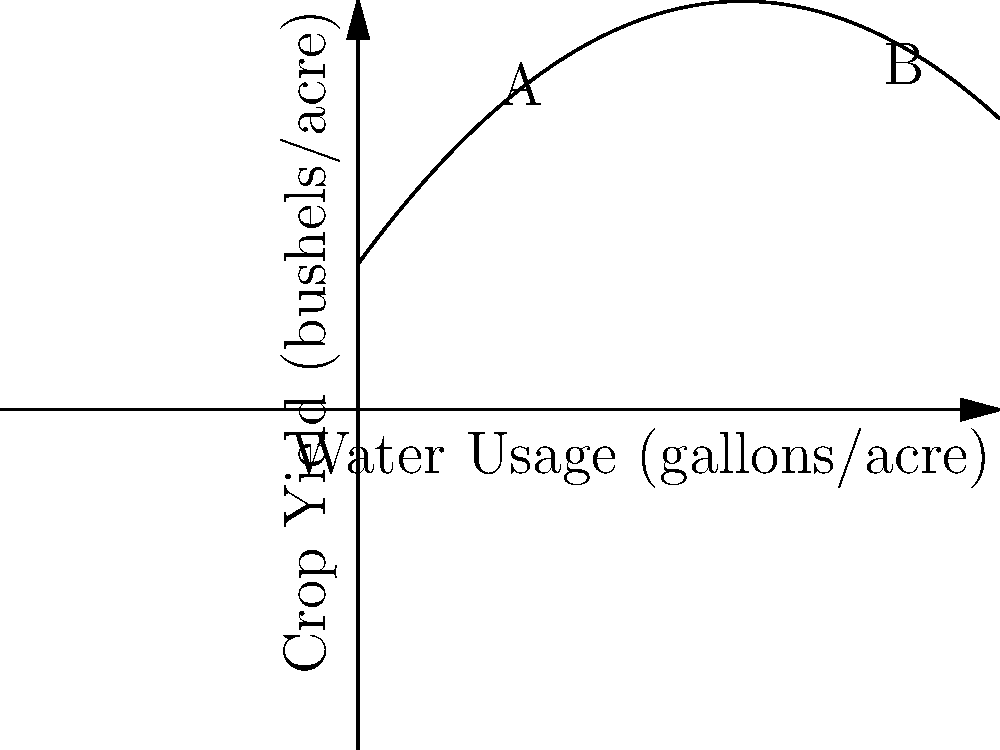A farmer is studying the relationship between water usage and crop yield for a new irrigation system. The polynomial $f(x)=-0.5x^2+6x+10$ models the crop yield (in bushels per acre) as a function of water usage (in gallons per acre), where $x$ represents hundreds of gallons. If the farmer increases water usage from 200 to 800 gallons per acre, what is the change in crop yield? To solve this problem, we need to follow these steps:

1) The water usage is given in hundreds of gallons, so:
   200 gallons = 2 hundred gallons
   800 gallons = 8 hundred gallons

2) We need to calculate the crop yield at these two points:

   At 200 gallons (x = 2):
   $f(2) = -0.5(2)^2 + 6(2) + 10$
   $= -0.5(4) + 12 + 10$
   $= -2 + 12 + 10 = 20$ bushels per acre

   At 800 gallons (x = 8):
   $f(8) = -0.5(8)^2 + 6(8) + 10$
   $= -0.5(64) + 48 + 10$
   $= -32 + 48 + 10 = 26$ bushels per acre

3) The change in crop yield is the difference between these two values:
   $26 - 20 = 6$ bushels per acre

Therefore, increasing water usage from 200 to 800 gallons per acre results in an increase of 6 bushels per acre in crop yield.
Answer: 6 bushels per acre 